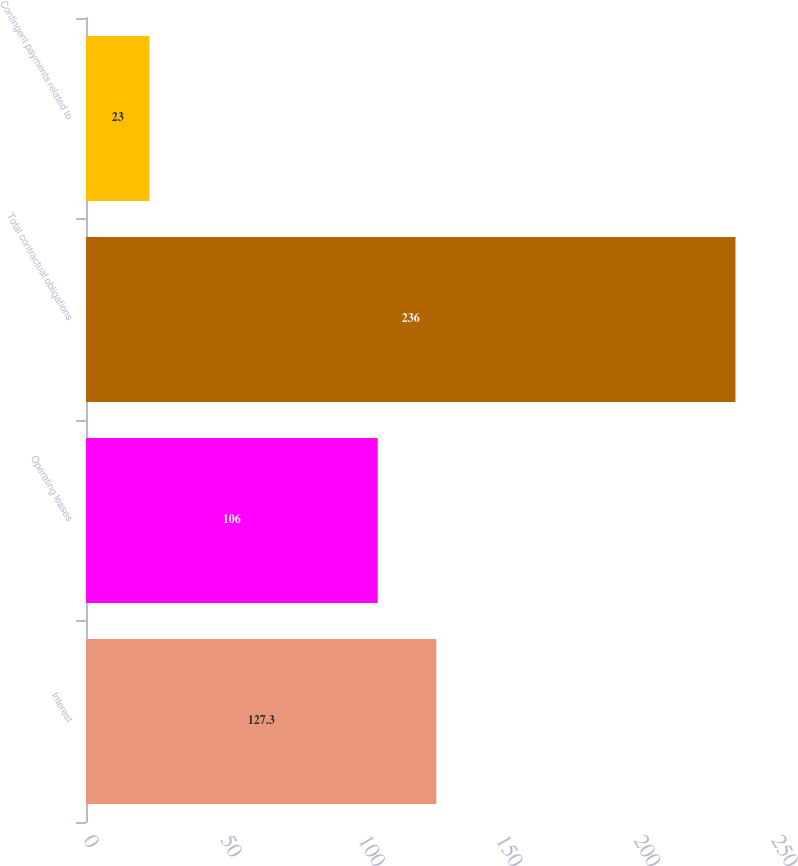Convert chart to OTSL. <chart><loc_0><loc_0><loc_500><loc_500><bar_chart><fcel>Interest<fcel>Operating leases<fcel>Total contractual obligations<fcel>Contingent payments related to<nl><fcel>127.3<fcel>106<fcel>236<fcel>23<nl></chart> 